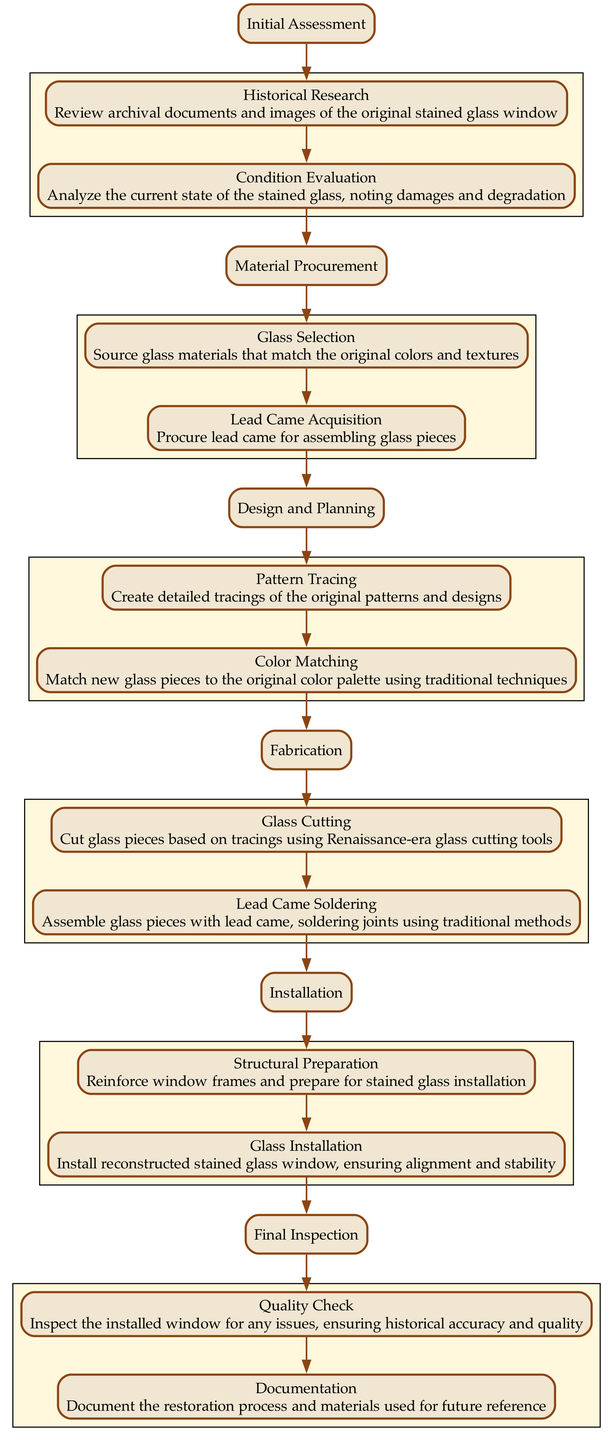What is the first step in the workflow? The first step listed in the diagram is "Initial Assessment." This can be found as the top node in the flow chart, indicating the starting point of the workflow process.
Answer: Initial Assessment How many actions are included in the "Design and Planning" step? In the "Design and Planning" step, there are two actions: "Pattern Tracing" and "Color Matching." The diagram lists these actions under this particular step, highlighting the tasks involved.
Answer: 2 What action follows "Glass Cutting"? According to the diagram, "Lead Came Soldering" follows "Glass Cutting" in the "Fabrication" step. By tracking the arrows, we see that after completing the glass cutting, the process moves to soldering the lead came.
Answer: Lead Came Soldering Which step involves "Quality Check"? The "Final Inspection" step includes the "Quality Check" action. By looking at the flow chart, we notice it is the last step where final evaluations are conducted on the installation.
Answer: Final Inspection What is the last action in the workflow? The last action in the workflow is "Documentation," which is part of the "Final Inspection" step. The diagram shows that this is the concluding task of the overall reconstruction process.
Answer: Documentation What are the components of the "Material Procurement" step? The "Material Procurement" step consists of two actions: "Glass Selection" and "Lead Came Acquisition." The diagram lists both tasks under this step, indicating what is needed for materials.
Answer: Glass Selection and Lead Came Acquisition Which two steps are directly connected? "Fabrication" and "Installation" are directly connected. From the diagram, there is an edge that leads from the last action in "Fabrication" to the first step of "Installation," indicating a direct flow from one phase to the next.
Answer: Fabrication and Installation Which action requires historical research? "Historical Research" is the action that requires historical investigation within the "Initial Assessment" step. By closely analyzing the diagram, we can pinpoint this task as the one related to understanding the past context of the stained glass windows.
Answer: Historical Research How many total steps are in the workflow? The total number of steps in the workflow is six. By counting the primary nodes in the flow chart, we identify each major step of the process from start to finish clearly outlined in the diagram.
Answer: 6 